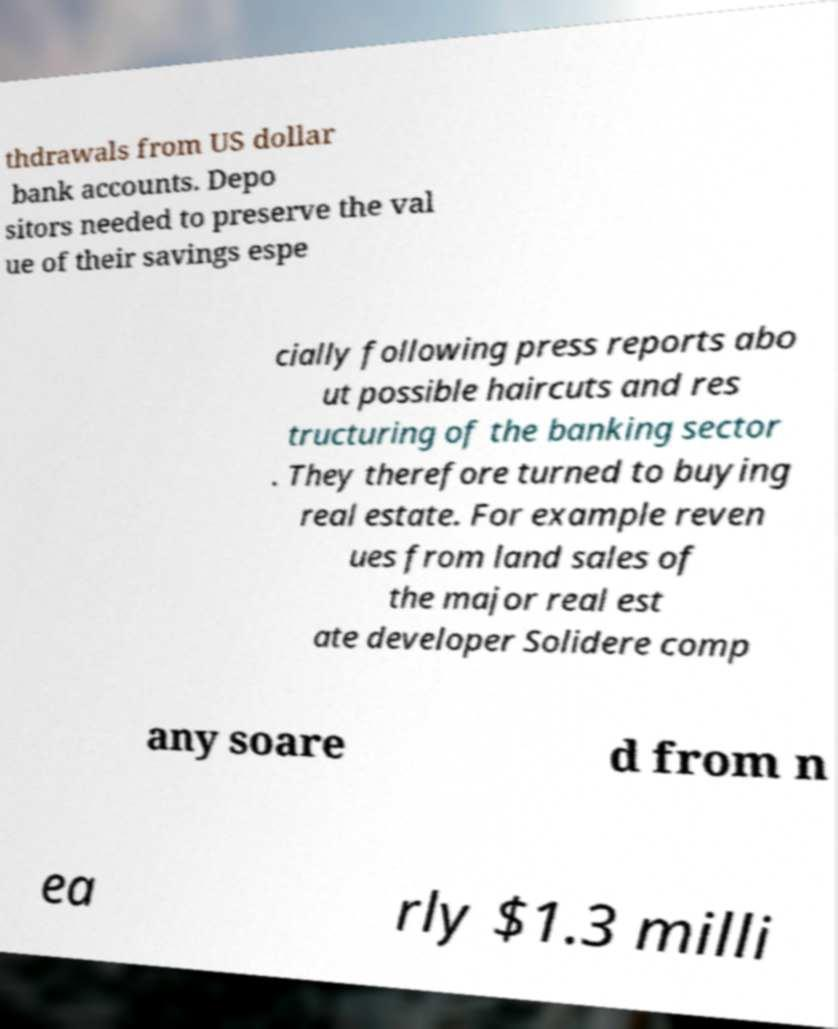There's text embedded in this image that I need extracted. Can you transcribe it verbatim? thdrawals from US dollar bank accounts. Depo sitors needed to preserve the val ue of their savings espe cially following press reports abo ut possible haircuts and res tructuring of the banking sector . They therefore turned to buying real estate. For example reven ues from land sales of the major real est ate developer Solidere comp any soare d from n ea rly $1.3 milli 